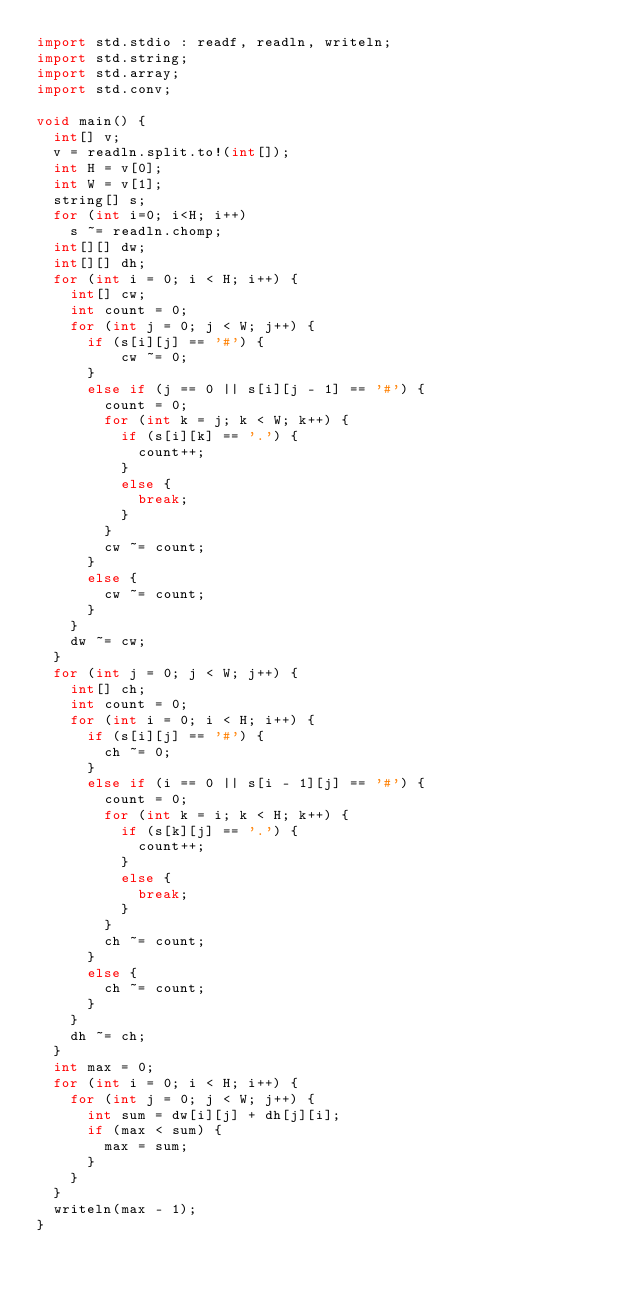<code> <loc_0><loc_0><loc_500><loc_500><_D_>import std.stdio : readf, readln, writeln;
import std.string;
import std.array;
import std.conv;

void main() {
  int[] v;
  v = readln.split.to!(int[]);
  int H = v[0];
  int W = v[1];
  string[] s;
  for (int i=0; i<H; i++)
    s ~= readln.chomp;
  int[][] dw;
  int[][] dh;
  for (int i = 0; i < H; i++) {
    int[] cw;
    int count = 0;
    for (int j = 0; j < W; j++) {
      if (s[i][j] == '#') {
          cw ~= 0;
      }
      else if (j == 0 || s[i][j - 1] == '#') {
        count = 0;
        for (int k = j; k < W; k++) {
          if (s[i][k] == '.') {
            count++;
          }
          else {
            break;
          }
        }
        cw ~= count;
      }
      else {
        cw ~= count;
      }
    }
    dw ~= cw;
  }
  for (int j = 0; j < W; j++) {
    int[] ch;
    int count = 0;
    for (int i = 0; i < H; i++) {
      if (s[i][j] == '#') {
        ch ~= 0;
      }
      else if (i == 0 || s[i - 1][j] == '#') {
        count = 0;
        for (int k = i; k < H; k++) {
          if (s[k][j] == '.') {
            count++;
          }
          else {
            break;
          }
        }
        ch ~= count;
      }
      else {
        ch ~= count;
      }
    }
    dh ~= ch;
  }
  int max = 0;
  for (int i = 0; i < H; i++) {
    for (int j = 0; j < W; j++) {
      int sum = dw[i][j] + dh[j][i];
      if (max < sum) {
        max = sum;
      }
    }
  }
  writeln(max - 1);
}
</code> 